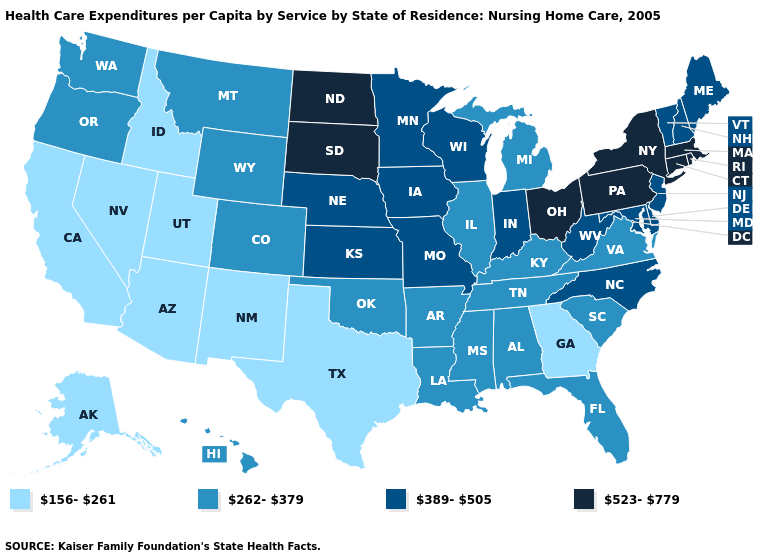Among the states that border Wyoming , which have the highest value?
Give a very brief answer. South Dakota. What is the lowest value in the USA?
Write a very short answer. 156-261. What is the value of Alaska?
Give a very brief answer. 156-261. Does Pennsylvania have a higher value than Rhode Island?
Keep it brief. No. What is the lowest value in the USA?
Be succinct. 156-261. Among the states that border Nevada , which have the highest value?
Be succinct. Oregon. What is the value of West Virginia?
Keep it brief. 389-505. What is the value of Hawaii?
Be succinct. 262-379. What is the value of South Dakota?
Quick response, please. 523-779. What is the highest value in the USA?
Give a very brief answer. 523-779. Does Hawaii have the highest value in the West?
Answer briefly. Yes. Among the states that border California , does Arizona have the lowest value?
Quick response, please. Yes. Does Utah have the highest value in the USA?
Answer briefly. No. Does Rhode Island have a lower value than Utah?
Answer briefly. No. What is the value of Rhode Island?
Quick response, please. 523-779. 